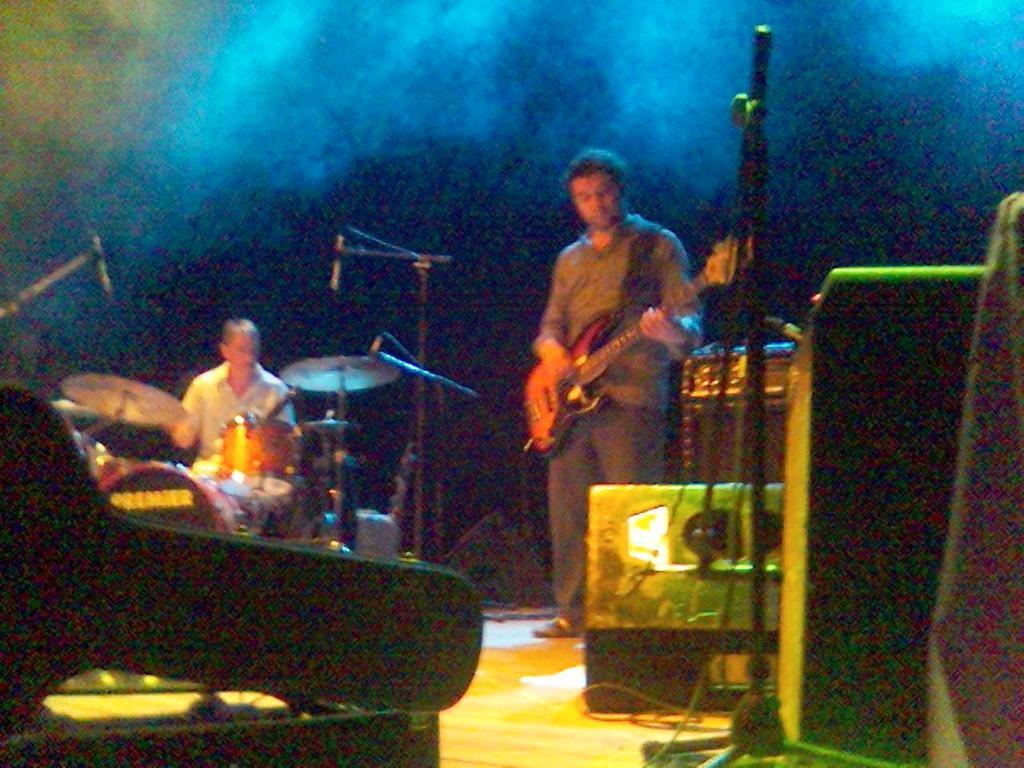Could you give a brief overview of what you see in this image? In this picture we can see two musicians, they are playing musical instruments in front of microphone. 